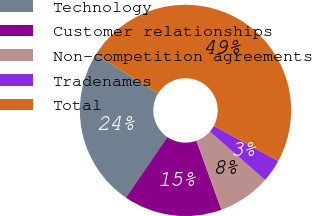Convert chart to OTSL. <chart><loc_0><loc_0><loc_500><loc_500><pie_chart><fcel>Technology<fcel>Customer relationships<fcel>Non-competition agreements<fcel>Tradenames<fcel>Total<nl><fcel>24.33%<fcel>15.07%<fcel>8.05%<fcel>3.49%<fcel>49.07%<nl></chart> 